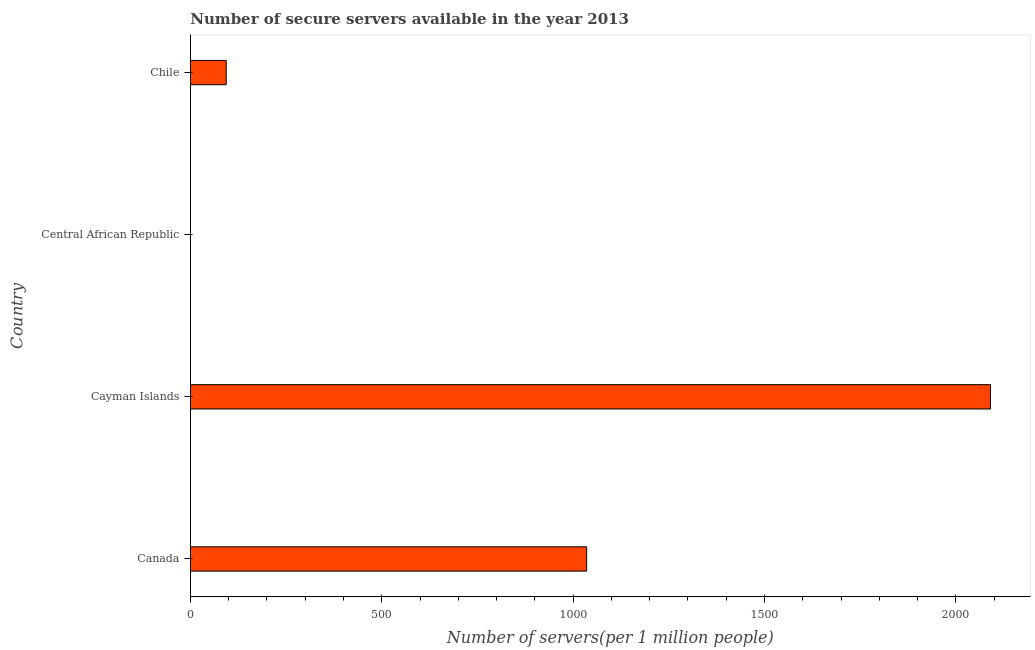What is the title of the graph?
Make the answer very short. Number of secure servers available in the year 2013. What is the label or title of the X-axis?
Offer a terse response. Number of servers(per 1 million people). What is the number of secure internet servers in Chile?
Offer a terse response. 93.82. Across all countries, what is the maximum number of secure internet servers?
Your answer should be compact. 2090.15. Across all countries, what is the minimum number of secure internet servers?
Offer a terse response. 0.21. In which country was the number of secure internet servers maximum?
Ensure brevity in your answer.  Cayman Islands. In which country was the number of secure internet servers minimum?
Give a very brief answer. Central African Republic. What is the sum of the number of secure internet servers?
Provide a short and direct response. 3219.45. What is the difference between the number of secure internet servers in Cayman Islands and Central African Republic?
Give a very brief answer. 2089.94. What is the average number of secure internet servers per country?
Give a very brief answer. 804.86. What is the median number of secure internet servers?
Your response must be concise. 564.54. In how many countries, is the number of secure internet servers greater than 1400 ?
Your response must be concise. 1. What is the ratio of the number of secure internet servers in Cayman Islands to that in Chile?
Keep it short and to the point. 22.28. Is the number of secure internet servers in Canada less than that in Cayman Islands?
Offer a very short reply. Yes. Is the difference between the number of secure internet servers in Canada and Central African Republic greater than the difference between any two countries?
Your answer should be compact. No. What is the difference between the highest and the second highest number of secure internet servers?
Offer a terse response. 1054.89. Is the sum of the number of secure internet servers in Cayman Islands and Chile greater than the maximum number of secure internet servers across all countries?
Offer a very short reply. Yes. What is the difference between the highest and the lowest number of secure internet servers?
Ensure brevity in your answer.  2089.94. In how many countries, is the number of secure internet servers greater than the average number of secure internet servers taken over all countries?
Offer a very short reply. 2. How many bars are there?
Your answer should be very brief. 4. Are all the bars in the graph horizontal?
Offer a terse response. Yes. How many countries are there in the graph?
Provide a succinct answer. 4. What is the difference between two consecutive major ticks on the X-axis?
Offer a very short reply. 500. What is the Number of servers(per 1 million people) of Canada?
Your answer should be very brief. 1035.26. What is the Number of servers(per 1 million people) in Cayman Islands?
Your answer should be very brief. 2090.15. What is the Number of servers(per 1 million people) of Central African Republic?
Make the answer very short. 0.21. What is the Number of servers(per 1 million people) of Chile?
Ensure brevity in your answer.  93.82. What is the difference between the Number of servers(per 1 million people) in Canada and Cayman Islands?
Your answer should be compact. -1054.89. What is the difference between the Number of servers(per 1 million people) in Canada and Central African Republic?
Provide a succinct answer. 1035.05. What is the difference between the Number of servers(per 1 million people) in Canada and Chile?
Your response must be concise. 941.44. What is the difference between the Number of servers(per 1 million people) in Cayman Islands and Central African Republic?
Ensure brevity in your answer.  2089.94. What is the difference between the Number of servers(per 1 million people) in Cayman Islands and Chile?
Provide a short and direct response. 1996.33. What is the difference between the Number of servers(per 1 million people) in Central African Republic and Chile?
Make the answer very short. -93.61. What is the ratio of the Number of servers(per 1 million people) in Canada to that in Cayman Islands?
Your response must be concise. 0.49. What is the ratio of the Number of servers(per 1 million people) in Canada to that in Central African Republic?
Provide a short and direct response. 4876.78. What is the ratio of the Number of servers(per 1 million people) in Canada to that in Chile?
Keep it short and to the point. 11.03. What is the ratio of the Number of servers(per 1 million people) in Cayman Islands to that in Central African Republic?
Your answer should be compact. 9846.03. What is the ratio of the Number of servers(per 1 million people) in Cayman Islands to that in Chile?
Provide a short and direct response. 22.28. What is the ratio of the Number of servers(per 1 million people) in Central African Republic to that in Chile?
Provide a succinct answer. 0. 